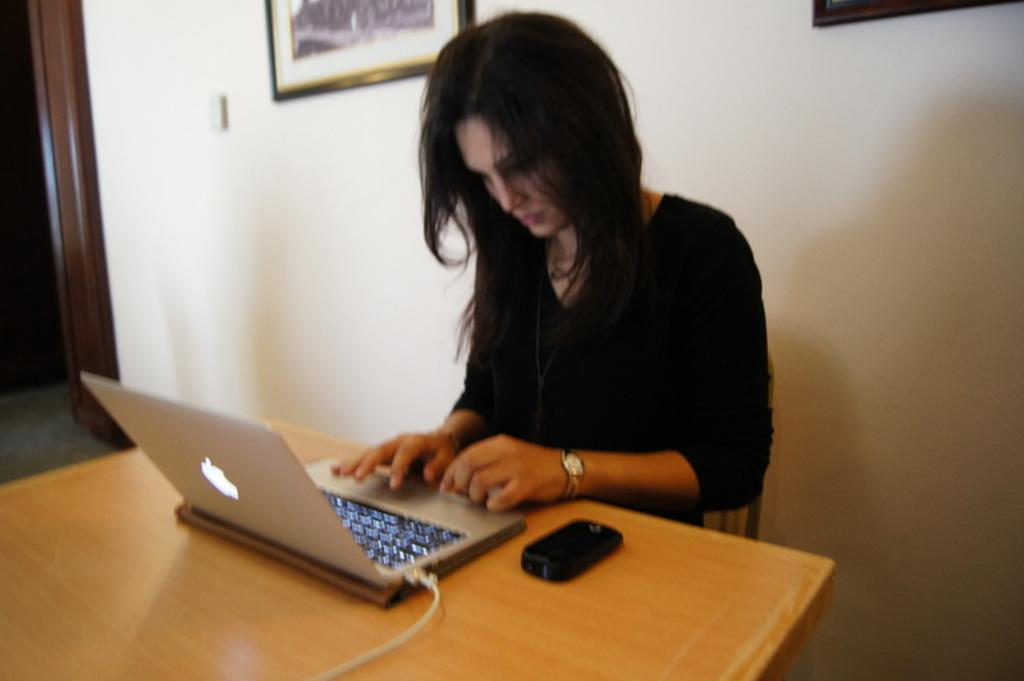What is the color of the wall in the image? The wall in the image is white. What can be seen hanging on the wall? There is a photo frame in the image. Who is sitting in the image? There is a woman sitting on a chair in the image. What furniture is present in the image? There is a table in the image. What electronic devices are on the table? There is a laptop and a mobile phone on the table. What type of blade is being used by the woman in the image? There is no blade present in the image; the woman is simply sitting on a chair. 